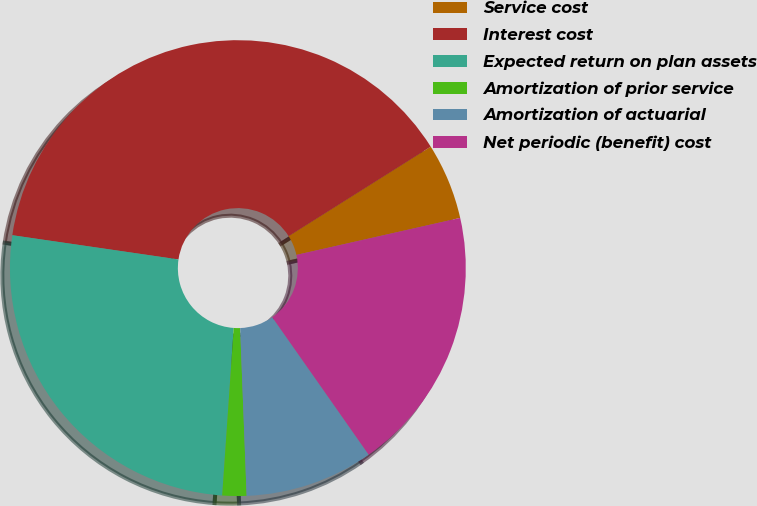<chart> <loc_0><loc_0><loc_500><loc_500><pie_chart><fcel>Service cost<fcel>Interest cost<fcel>Expected return on plan assets<fcel>Amortization of prior service<fcel>Amortization of actuarial<fcel>Net periodic (benefit) cost<nl><fcel>5.41%<fcel>38.75%<fcel>26.21%<fcel>1.71%<fcel>9.12%<fcel>18.8%<nl></chart> 